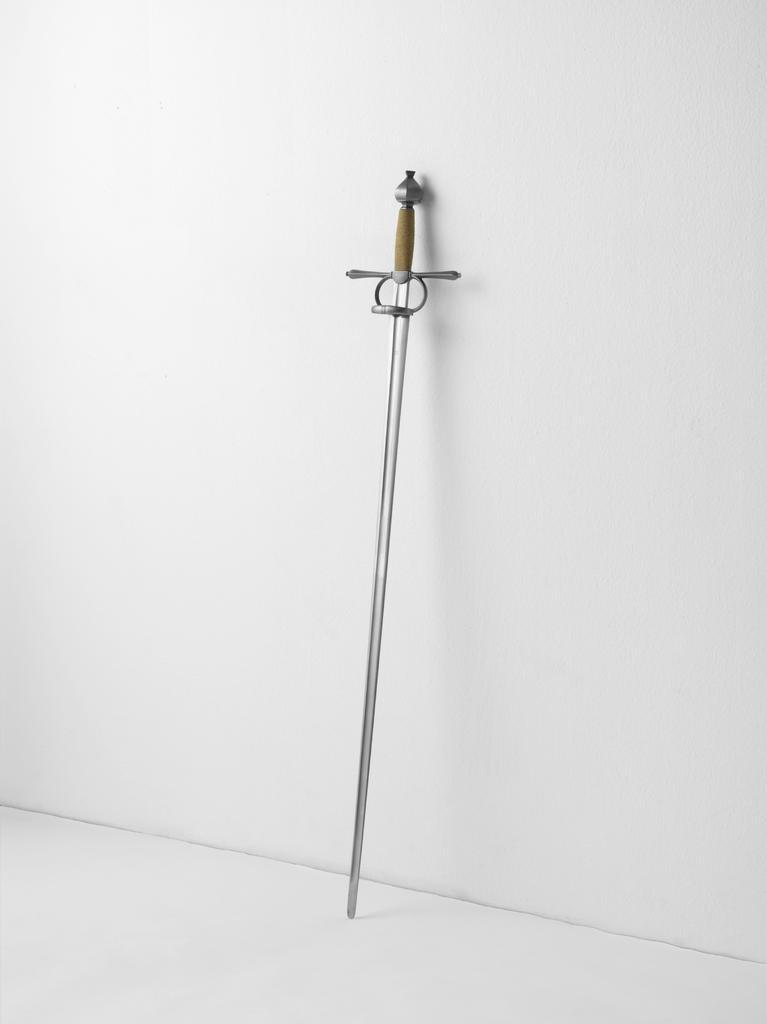Please provide a concise description of this image. In the image we can see there is a sword kept near the wall and the wall is in white colour. 